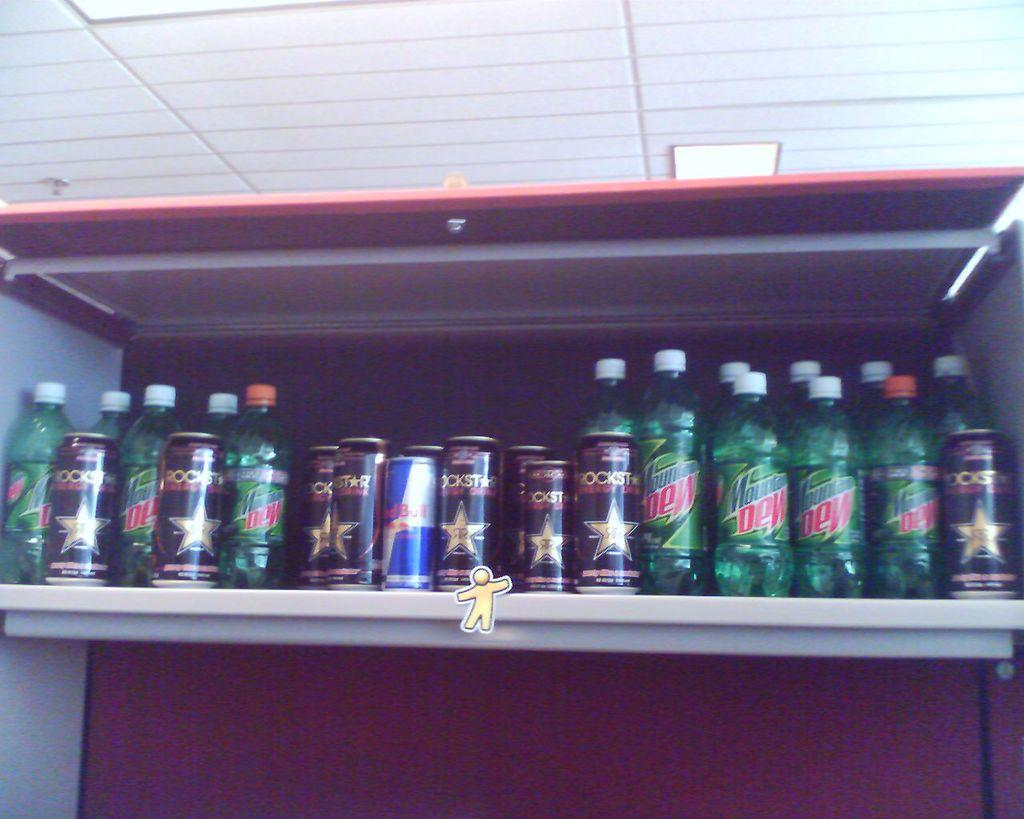<image>
Create a compact narrative representing the image presented. a Mountain Dew bottle sitting on the shelf of a store 